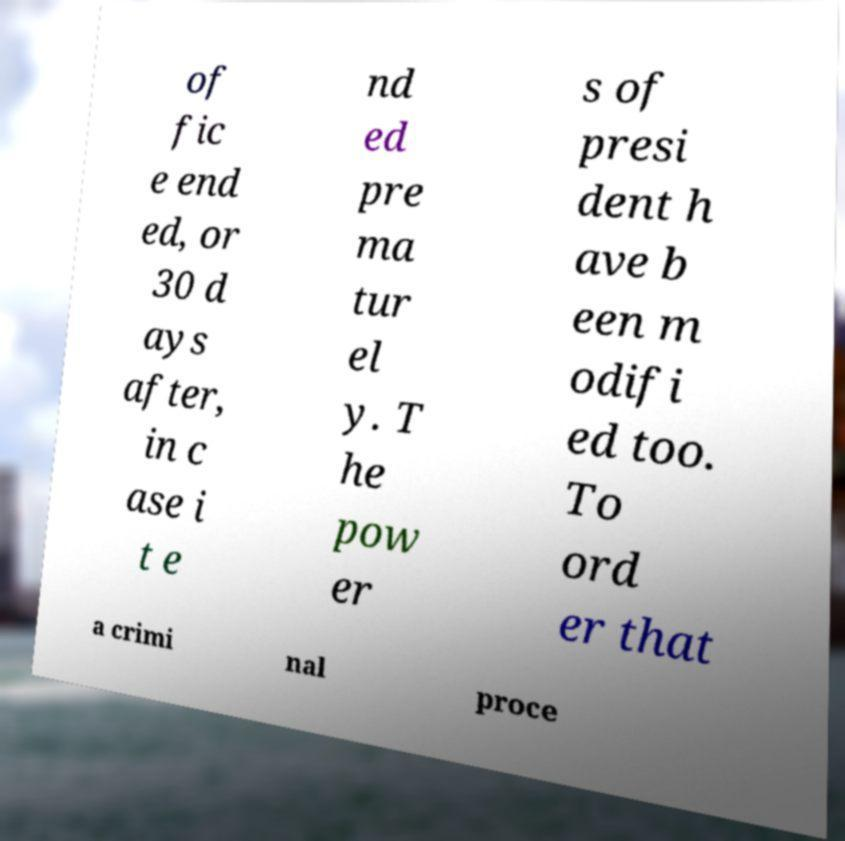Please read and relay the text visible in this image. What does it say? of fic e end ed, or 30 d ays after, in c ase i t e nd ed pre ma tur el y. T he pow er s of presi dent h ave b een m odifi ed too. To ord er that a crimi nal proce 